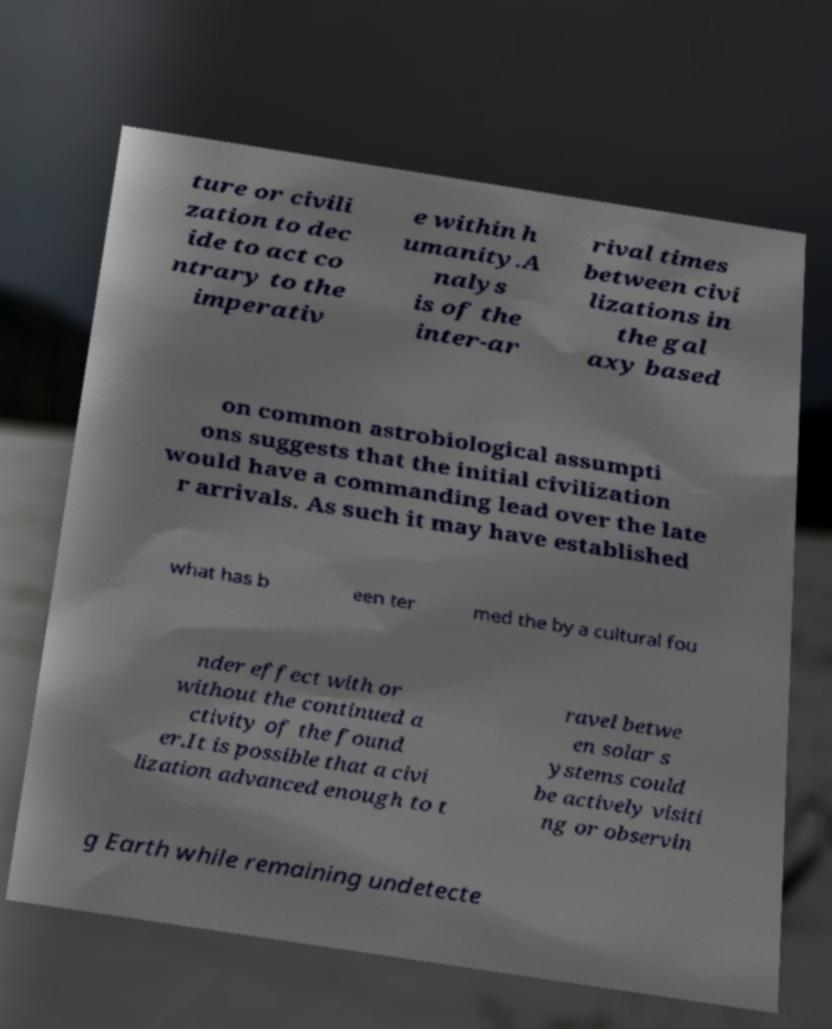Could you extract and type out the text from this image? ture or civili zation to dec ide to act co ntrary to the imperativ e within h umanity.A nalys is of the inter-ar rival times between civi lizations in the gal axy based on common astrobiological assumpti ons suggests that the initial civilization would have a commanding lead over the late r arrivals. As such it may have established what has b een ter med the by a cultural fou nder effect with or without the continued a ctivity of the found er.It is possible that a civi lization advanced enough to t ravel betwe en solar s ystems could be actively visiti ng or observin g Earth while remaining undetecte 